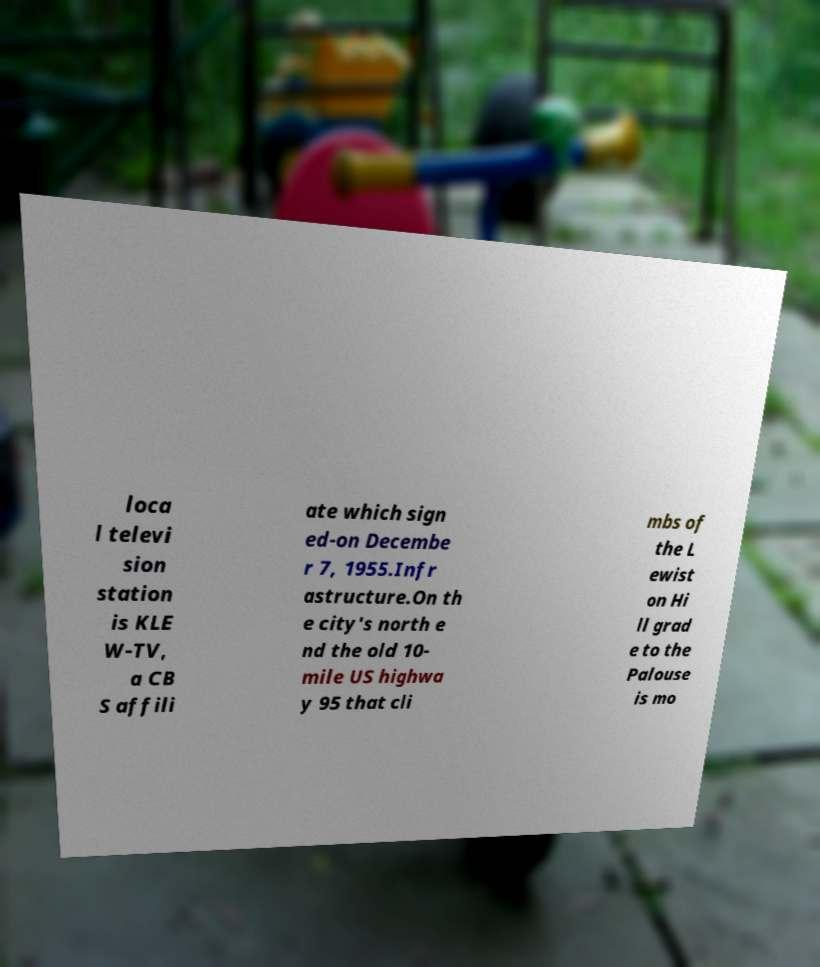Please read and relay the text visible in this image. What does it say? loca l televi sion station is KLE W-TV, a CB S affili ate which sign ed-on Decembe r 7, 1955.Infr astructure.On th e city's north e nd the old 10- mile US highwa y 95 that cli mbs of the L ewist on Hi ll grad e to the Palouse is mo 